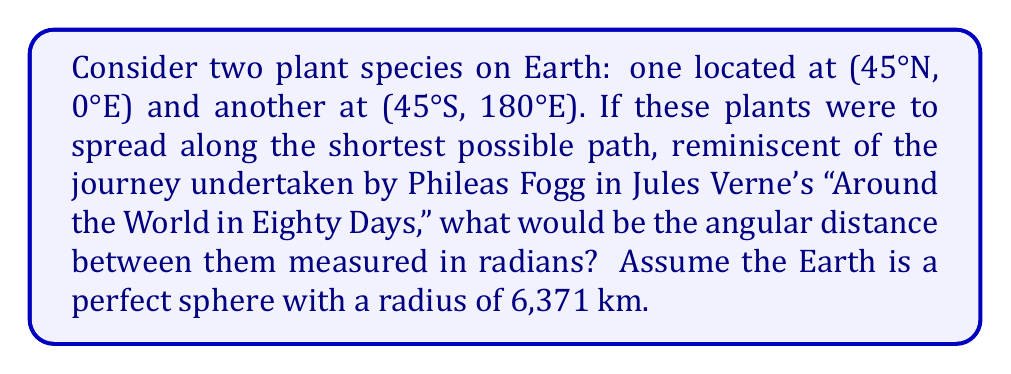Give your solution to this math problem. Let's approach this step-by-step, drawing parallels to the grand voyages often described in Victorian literature:

1) The shortest path between two points on a sphere is along a great circle, much like the efficient route Phileas Fogg would have sought.

2) To find the angular distance, we'll use the spherical law of cosines:

   $$\cos(c) = \sin(a)\sin(b) + \cos(a)\cos(b)\cos(C)$$

   Where:
   $a$ and $b$ are the co-latitudes of the two points
   $C$ is the difference in longitude
   $c$ is the angular distance we're seeking

3) Let's determine our values:
   - For (45°N, 0°E): co-latitude $a = 90° - 45° = 45°$
   - For (45°S, 180°E): co-latitude $b = 90° + 45° = 135°$
   - Longitude difference $C = 180° - 0° = 180°$

4) Converting to radians:
   $a = 45° \times \frac{\pi}{180°} = \frac{\pi}{4}$
   $b = 135° \times \frac{\pi}{180°} = \frac{3\pi}{4}$
   $C = 180° \times \frac{\pi}{180°} = \pi$

5) Applying the formula:

   $$\cos(c) = \sin(\frac{\pi}{4})\sin(\frac{3\pi}{4}) + \cos(\frac{\pi}{4})\cos(\frac{3\pi}{4})\cos(\pi)$$

6) Simplify:
   $$\cos(c) = \frac{\sqrt{2}}{2} \cdot \frac{\sqrt{2}}{2} + \frac{\sqrt{2}}{2} \cdot (-\frac{\sqrt{2}}{2}) \cdot (-1)$$
   $$\cos(c) = \frac{1}{2} + \frac{1}{2} = 1$$

7) Therefore:
   $$c = \arccos(1) = 0$$

This journey through mathematical space, much like a journey through the pages of a Victorian novel, leads us to an intriguing conclusion. The angular distance is 0 radians, meaning these points are actually antipodal – on opposite sides of the Earth.
Answer: 0 radians 